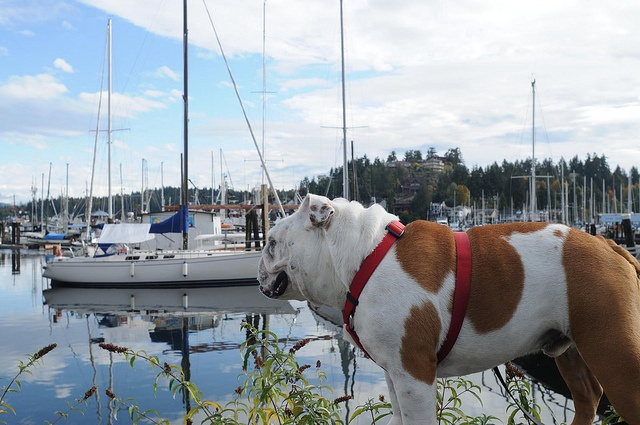Describe the objects in this image and their specific colors. I can see dog in lightblue, darkgray, black, gray, and maroon tones, boat in lightblue, darkgray, and gray tones, boat in lightblue, gray, darkgray, black, and lightgray tones, boat in lightblue, gray, darkgray, black, and blue tones, and people in lightblue, gray, maroon, brown, and black tones in this image. 